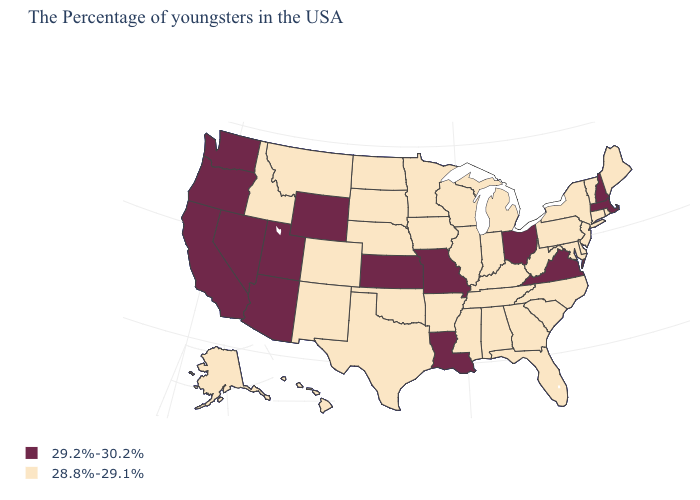Does the map have missing data?
Keep it brief. No. What is the value of Arkansas?
Concise answer only. 28.8%-29.1%. Which states hav the highest value in the MidWest?
Be succinct. Ohio, Missouri, Kansas. Which states have the lowest value in the MidWest?
Keep it brief. Michigan, Indiana, Wisconsin, Illinois, Minnesota, Iowa, Nebraska, South Dakota, North Dakota. Which states hav the highest value in the MidWest?
Quick response, please. Ohio, Missouri, Kansas. Among the states that border Oregon , which have the lowest value?
Be succinct. Idaho. What is the value of Missouri?
Concise answer only. 29.2%-30.2%. Among the states that border New Mexico , does Texas have the highest value?
Write a very short answer. No. Does Alaska have the same value as Rhode Island?
Be succinct. Yes. What is the highest value in states that border Massachusetts?
Concise answer only. 29.2%-30.2%. Does North Dakota have the highest value in the MidWest?
Short answer required. No. What is the highest value in the West ?
Write a very short answer. 29.2%-30.2%. Name the states that have a value in the range 29.2%-30.2%?
Keep it brief. Massachusetts, New Hampshire, Virginia, Ohio, Louisiana, Missouri, Kansas, Wyoming, Utah, Arizona, Nevada, California, Washington, Oregon. Does the first symbol in the legend represent the smallest category?
Quick response, please. No. Name the states that have a value in the range 28.8%-29.1%?
Give a very brief answer. Maine, Rhode Island, Vermont, Connecticut, New York, New Jersey, Delaware, Maryland, Pennsylvania, North Carolina, South Carolina, West Virginia, Florida, Georgia, Michigan, Kentucky, Indiana, Alabama, Tennessee, Wisconsin, Illinois, Mississippi, Arkansas, Minnesota, Iowa, Nebraska, Oklahoma, Texas, South Dakota, North Dakota, Colorado, New Mexico, Montana, Idaho, Alaska, Hawaii. 